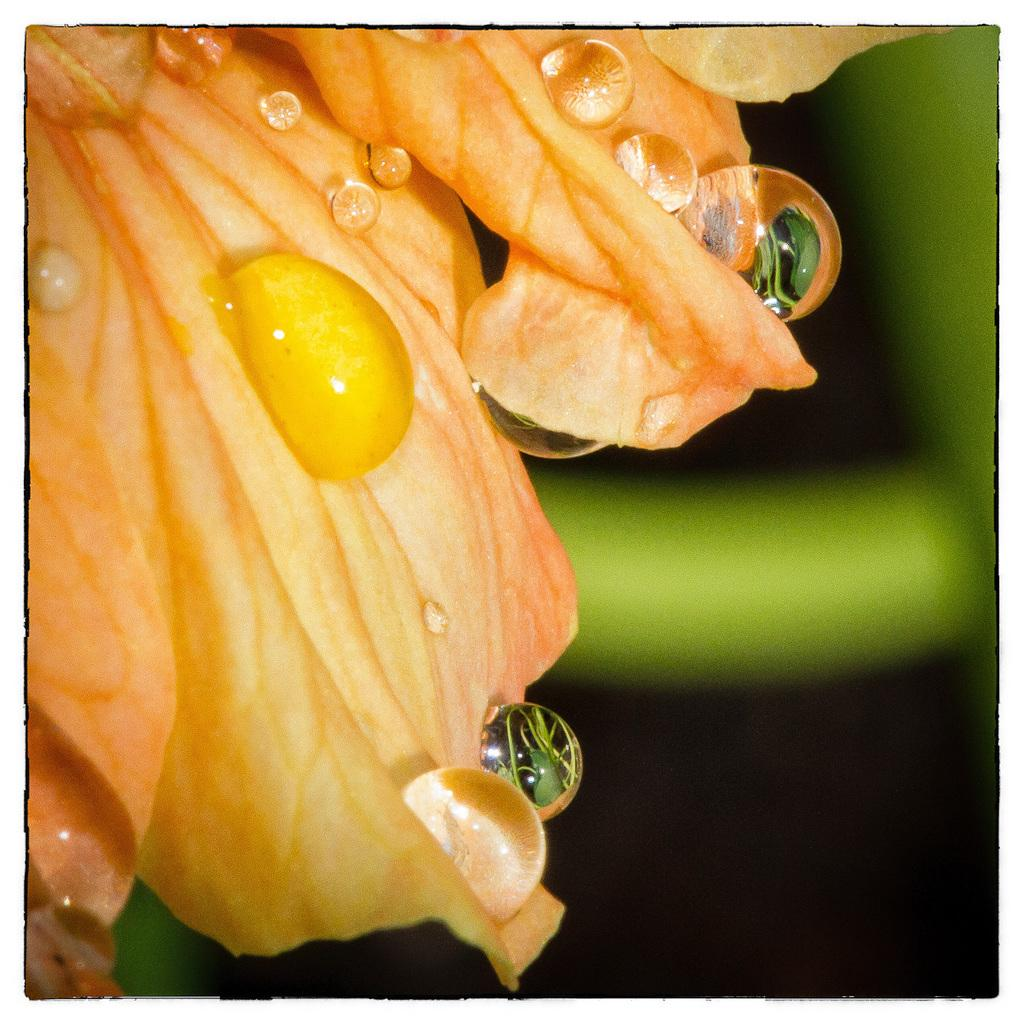What is the main subject of the image? There is a flower in the image. What can be observed on the flower? There are water drops on the flower. Can you describe the background of the image? The background of the image is blurred. What type of teeth can be seen on the flower in the image? There are no teeth present on the flower in the image. 